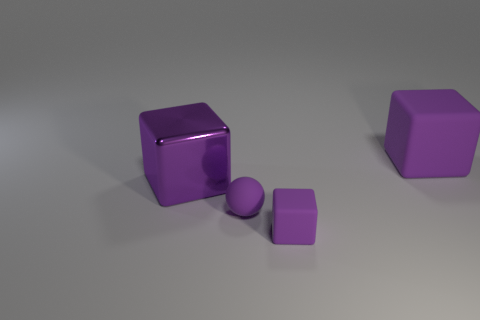Add 4 balls. How many objects exist? 8 Subtract all spheres. How many objects are left? 3 Subtract all small gray metallic cylinders. Subtract all small purple matte things. How many objects are left? 2 Add 4 metallic blocks. How many metallic blocks are left? 5 Add 3 yellow metal balls. How many yellow metal balls exist? 3 Subtract 0 gray cylinders. How many objects are left? 4 